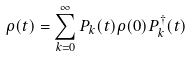<formula> <loc_0><loc_0><loc_500><loc_500>\rho ( t ) = \sum _ { k = 0 } ^ { \infty } P _ { k } ( t ) \rho ( 0 ) P ^ { \dagger } _ { k } ( t )</formula> 